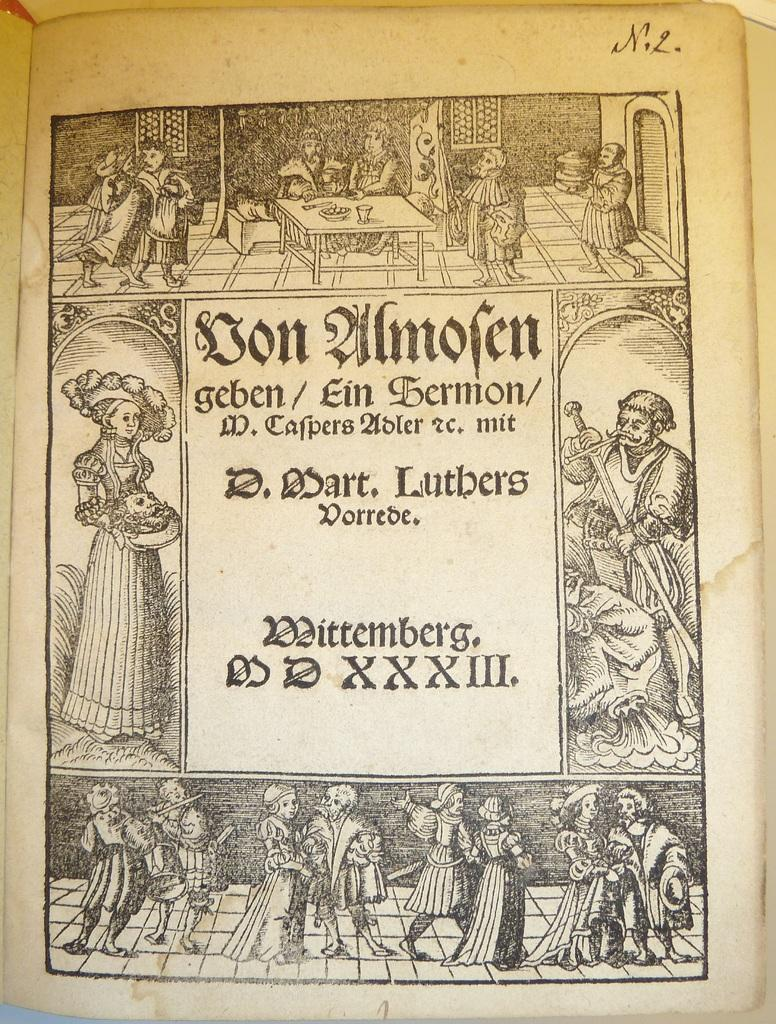How many people are in the image? There are persons in the image. What is one piece of furniture visible in the image? There is a table in the image. What type of objects can be seen in the image? There are objects in the image. What is a structural element visible in the image? There is a wall in the image. What architectural feature is present in the image? There is a door in the image. What allows natural light to enter the space in the image? There are windows in the image. What surface is the table and other objects resting on in the image? There is a floor in the image. Is there any text present in the image? Yes, there is some text in the image. How many girls are participating in the activity shown in the image? There is no activity or girls present in the image. What type of sheet is covering the table in the image? There is no sheet covering the table in the image. 